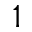Convert formula to latex. <formula><loc_0><loc_0><loc_500><loc_500>^ { 1 }</formula> 